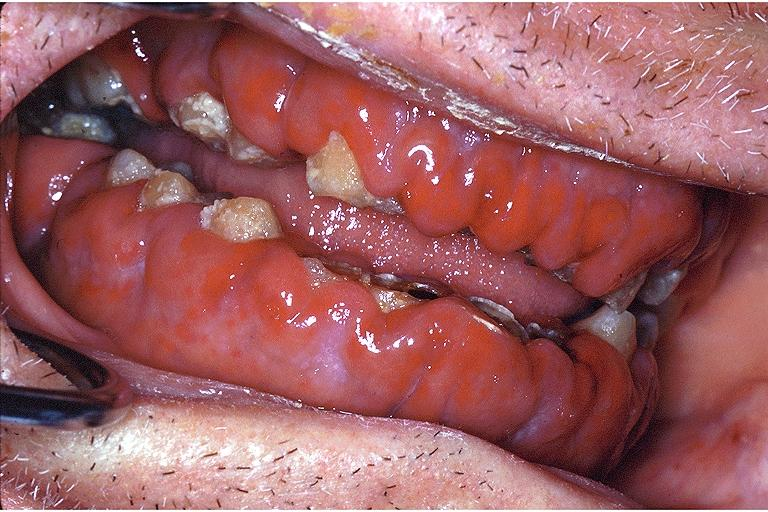s oral present?
Answer the question using a single word or phrase. Yes 